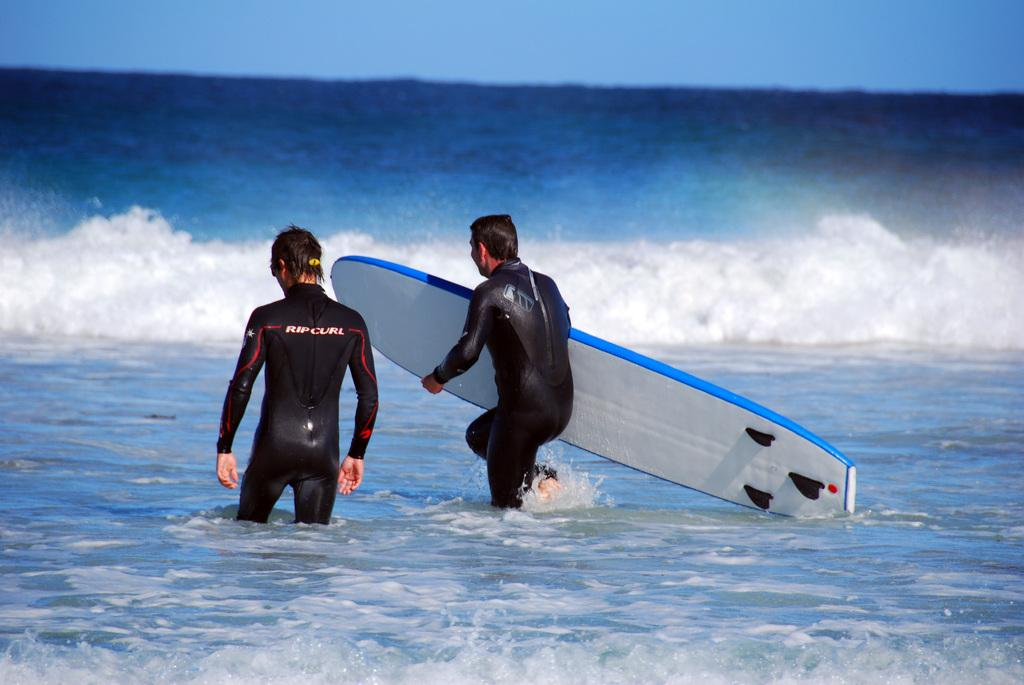How many people are in the water in the image? There are two persons in the water in the image. What is one person holding in the image? One person is holding a surfboard. What can be seen at the top of the image? The sky is visible at the top of the image. What type of string is being used to play chess in the image? There is no string or chess game present in the image; it features two persons in the water and a person holding a surfboard. 